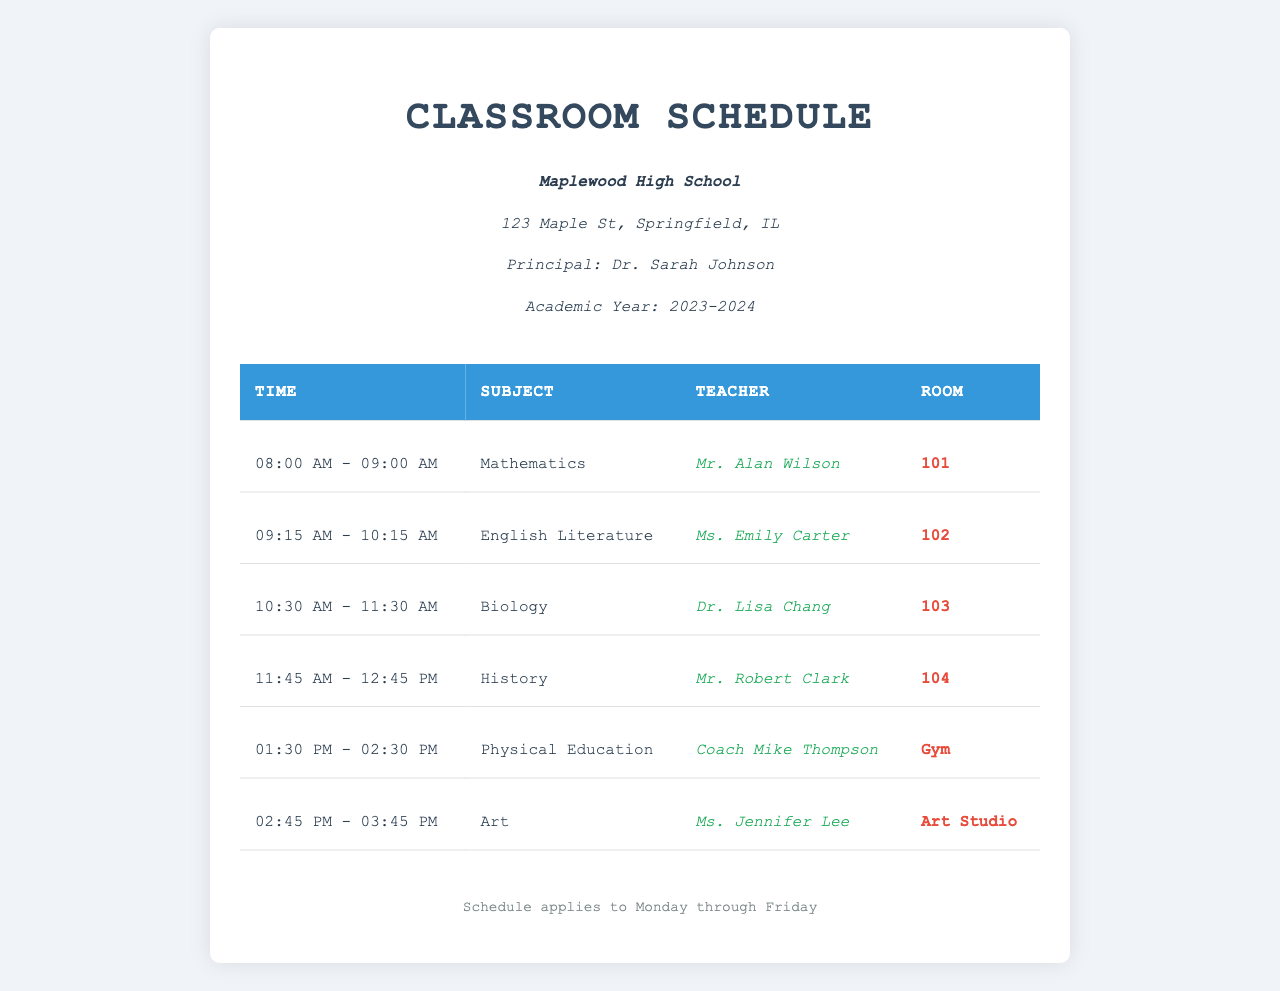what is the name of the school? The name of the school is mentioned at the beginning of the document under the school information section.
Answer: Maplewood High School who is the principal? The principal's name is provided directly in the school information section of the document.
Answer: Dr. Sarah Johnson what is the time for Physical Education class? The schedule lists the time for Physical Education class, which is specified in the table.
Answer: 01:30 PM - 02:30 PM how many subjects are listed in the schedule? The number of subjects can be counted by observing the rows of the table containing subject names.
Answer: 6 which room is assigned for Biology? The room assigned for Biology is indicated in the schedule under the corresponding subject.
Answer: 103 which teacher is assigned to Art? The schedule specifies the teacher for Art, which is detailed in the table.
Answer: Ms. Jennifer Lee what subject is Mr. Alan Wilson teaching? Mr. Alan Wilson's subject is listed in the table next to his name.
Answer: Mathematics what type of document is this? The content of the document is focused on a specific aspect related to the school and includes a schedule format.
Answer: Classroom Schedule what is the color of the header in the table? The header's color is determined by inspecting the style applied to the table in the document.
Answer: Blue 